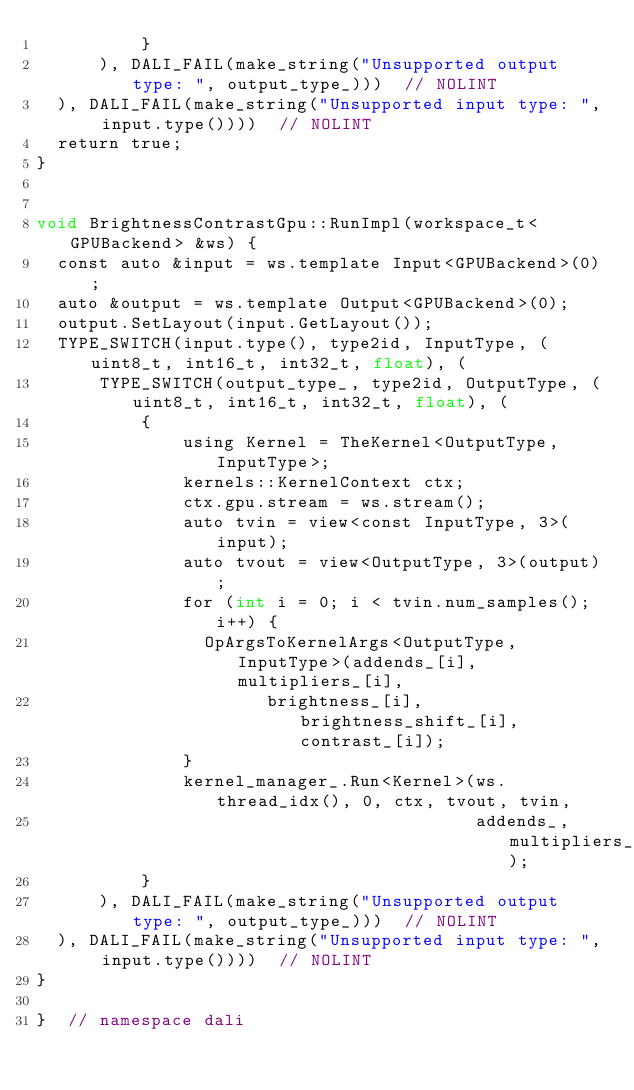<code> <loc_0><loc_0><loc_500><loc_500><_Cuda_>          }
      ), DALI_FAIL(make_string("Unsupported output type: ", output_type_)))  // NOLINT
  ), DALI_FAIL(make_string("Unsupported input type: ", input.type())))  // NOLINT
  return true;
}


void BrightnessContrastGpu::RunImpl(workspace_t<GPUBackend> &ws) {
  const auto &input = ws.template Input<GPUBackend>(0);
  auto &output = ws.template Output<GPUBackend>(0);
  output.SetLayout(input.GetLayout());
  TYPE_SWITCH(input.type(), type2id, InputType, (uint8_t, int16_t, int32_t, float), (
      TYPE_SWITCH(output_type_, type2id, OutputType, (uint8_t, int16_t, int32_t, float), (
          {
              using Kernel = TheKernel<OutputType, InputType>;
              kernels::KernelContext ctx;
              ctx.gpu.stream = ws.stream();
              auto tvin = view<const InputType, 3>(input);
              auto tvout = view<OutputType, 3>(output);
              for (int i = 0; i < tvin.num_samples(); i++) {
                OpArgsToKernelArgs<OutputType, InputType>(addends_[i], multipliers_[i],
                      brightness_[i], brightness_shift_[i], contrast_[i]);
              }
              kernel_manager_.Run<Kernel>(ws.thread_idx(), 0, ctx, tvout, tvin,
                                          addends_, multipliers_);
          }
      ), DALI_FAIL(make_string("Unsupported output type: ", output_type_)))  // NOLINT
  ), DALI_FAIL(make_string("Unsupported input type: ", input.type())))  // NOLINT
}

}  // namespace dali
</code> 